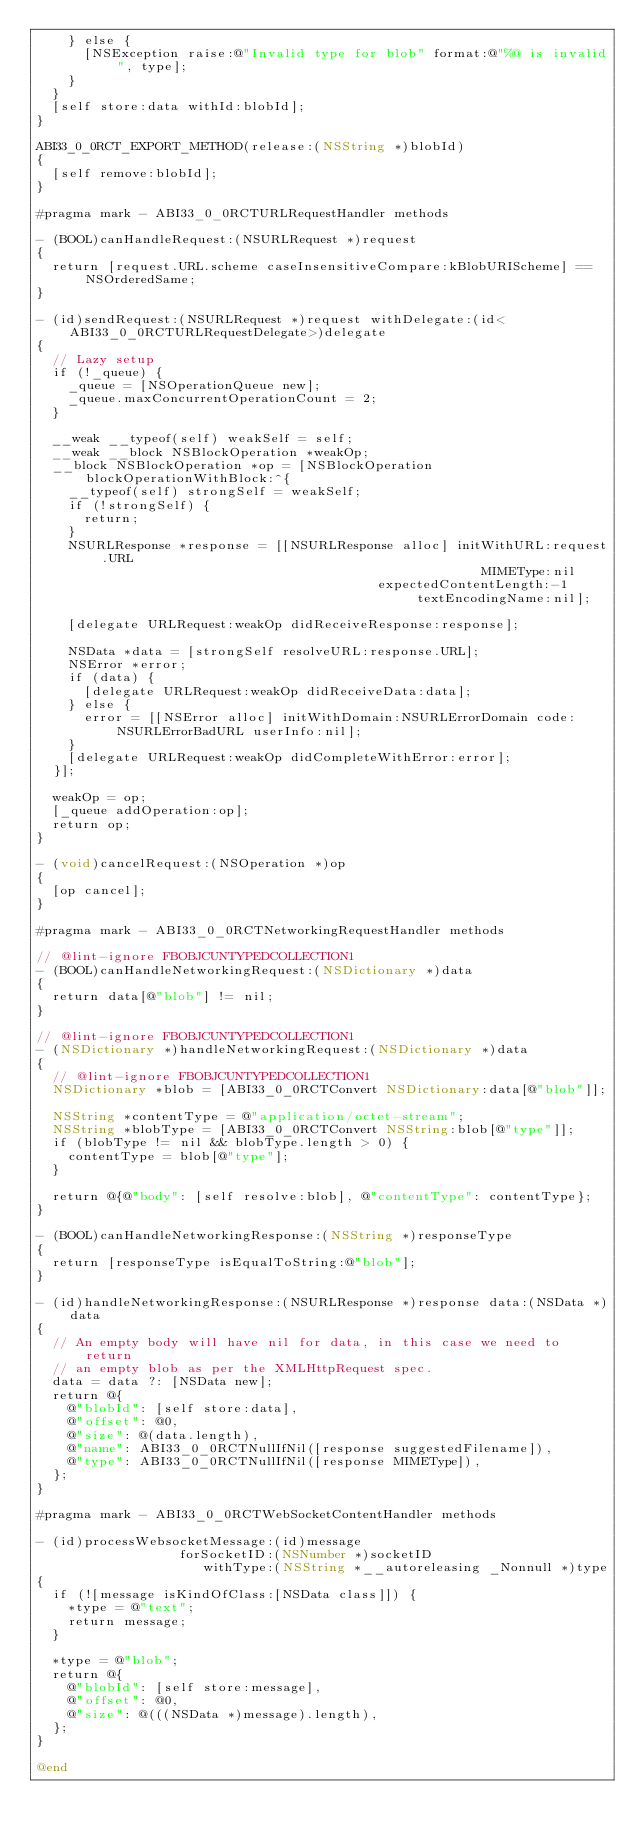<code> <loc_0><loc_0><loc_500><loc_500><_ObjectiveC_>    } else {
      [NSException raise:@"Invalid type for blob" format:@"%@ is invalid", type];
    }
  }
  [self store:data withId:blobId];
}

ABI33_0_0RCT_EXPORT_METHOD(release:(NSString *)blobId)
{
  [self remove:blobId];
}

#pragma mark - ABI33_0_0RCTURLRequestHandler methods

- (BOOL)canHandleRequest:(NSURLRequest *)request
{
  return [request.URL.scheme caseInsensitiveCompare:kBlobURIScheme] == NSOrderedSame;
}

- (id)sendRequest:(NSURLRequest *)request withDelegate:(id<ABI33_0_0RCTURLRequestDelegate>)delegate
{
  // Lazy setup
  if (!_queue) {
    _queue = [NSOperationQueue new];
    _queue.maxConcurrentOperationCount = 2;
  }

  __weak __typeof(self) weakSelf = self;
  __weak __block NSBlockOperation *weakOp;
  __block NSBlockOperation *op = [NSBlockOperation blockOperationWithBlock:^{
    __typeof(self) strongSelf = weakSelf;
    if (!strongSelf) {
      return;
    }
    NSURLResponse *response = [[NSURLResponse alloc] initWithURL:request.URL
                                                        MIMEType:nil
                                           expectedContentLength:-1
                                                textEncodingName:nil];

    [delegate URLRequest:weakOp didReceiveResponse:response];

    NSData *data = [strongSelf resolveURL:response.URL];
    NSError *error;
    if (data) {
      [delegate URLRequest:weakOp didReceiveData:data];
    } else {
      error = [[NSError alloc] initWithDomain:NSURLErrorDomain code:NSURLErrorBadURL userInfo:nil];
    }
    [delegate URLRequest:weakOp didCompleteWithError:error];
  }];

  weakOp = op;
  [_queue addOperation:op];
  return op;
}

- (void)cancelRequest:(NSOperation *)op
{
  [op cancel];
}

#pragma mark - ABI33_0_0RCTNetworkingRequestHandler methods

// @lint-ignore FBOBJCUNTYPEDCOLLECTION1
- (BOOL)canHandleNetworkingRequest:(NSDictionary *)data
{
  return data[@"blob"] != nil;
}

// @lint-ignore FBOBJCUNTYPEDCOLLECTION1
- (NSDictionary *)handleNetworkingRequest:(NSDictionary *)data
{
  // @lint-ignore FBOBJCUNTYPEDCOLLECTION1
  NSDictionary *blob = [ABI33_0_0RCTConvert NSDictionary:data[@"blob"]];

  NSString *contentType = @"application/octet-stream";
  NSString *blobType = [ABI33_0_0RCTConvert NSString:blob[@"type"]];
  if (blobType != nil && blobType.length > 0) {
    contentType = blob[@"type"];
  }

  return @{@"body": [self resolve:blob], @"contentType": contentType};
}

- (BOOL)canHandleNetworkingResponse:(NSString *)responseType
{
  return [responseType isEqualToString:@"blob"];
}

- (id)handleNetworkingResponse:(NSURLResponse *)response data:(NSData *)data
{
  // An empty body will have nil for data, in this case we need to return
  // an empty blob as per the XMLHttpRequest spec.
  data = data ?: [NSData new];
  return @{
    @"blobId": [self store:data],
    @"offset": @0,
    @"size": @(data.length),
    @"name": ABI33_0_0RCTNullIfNil([response suggestedFilename]),
    @"type": ABI33_0_0RCTNullIfNil([response MIMEType]),
  };
}

#pragma mark - ABI33_0_0RCTWebSocketContentHandler methods

- (id)processWebsocketMessage:(id)message
                  forSocketID:(NSNumber *)socketID
                     withType:(NSString *__autoreleasing _Nonnull *)type
{
  if (![message isKindOfClass:[NSData class]]) {
    *type = @"text";
    return message;
  }

  *type = @"blob";
  return @{
    @"blobId": [self store:message],
    @"offset": @0,
    @"size": @(((NSData *)message).length),
  };
}

@end
</code> 